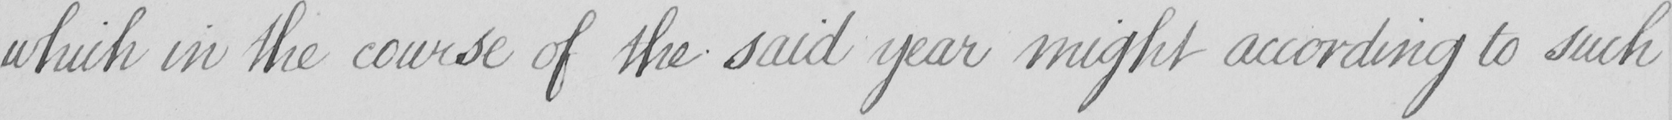Please provide the text content of this handwritten line. which in the course of the said year might according to such 